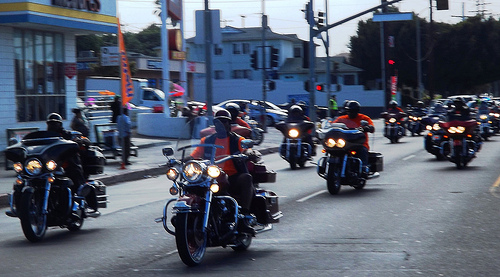<image>
Can you confirm if the person is on the motorcycle? Yes. Looking at the image, I can see the person is positioned on top of the motorcycle, with the motorcycle providing support. Is the motorcycle under the man? Yes. The motorcycle is positioned underneath the man, with the man above it in the vertical space. Where is the man in relation to the motorcycle? Is it next to the motorcycle? No. The man is not positioned next to the motorcycle. They are located in different areas of the scene. 